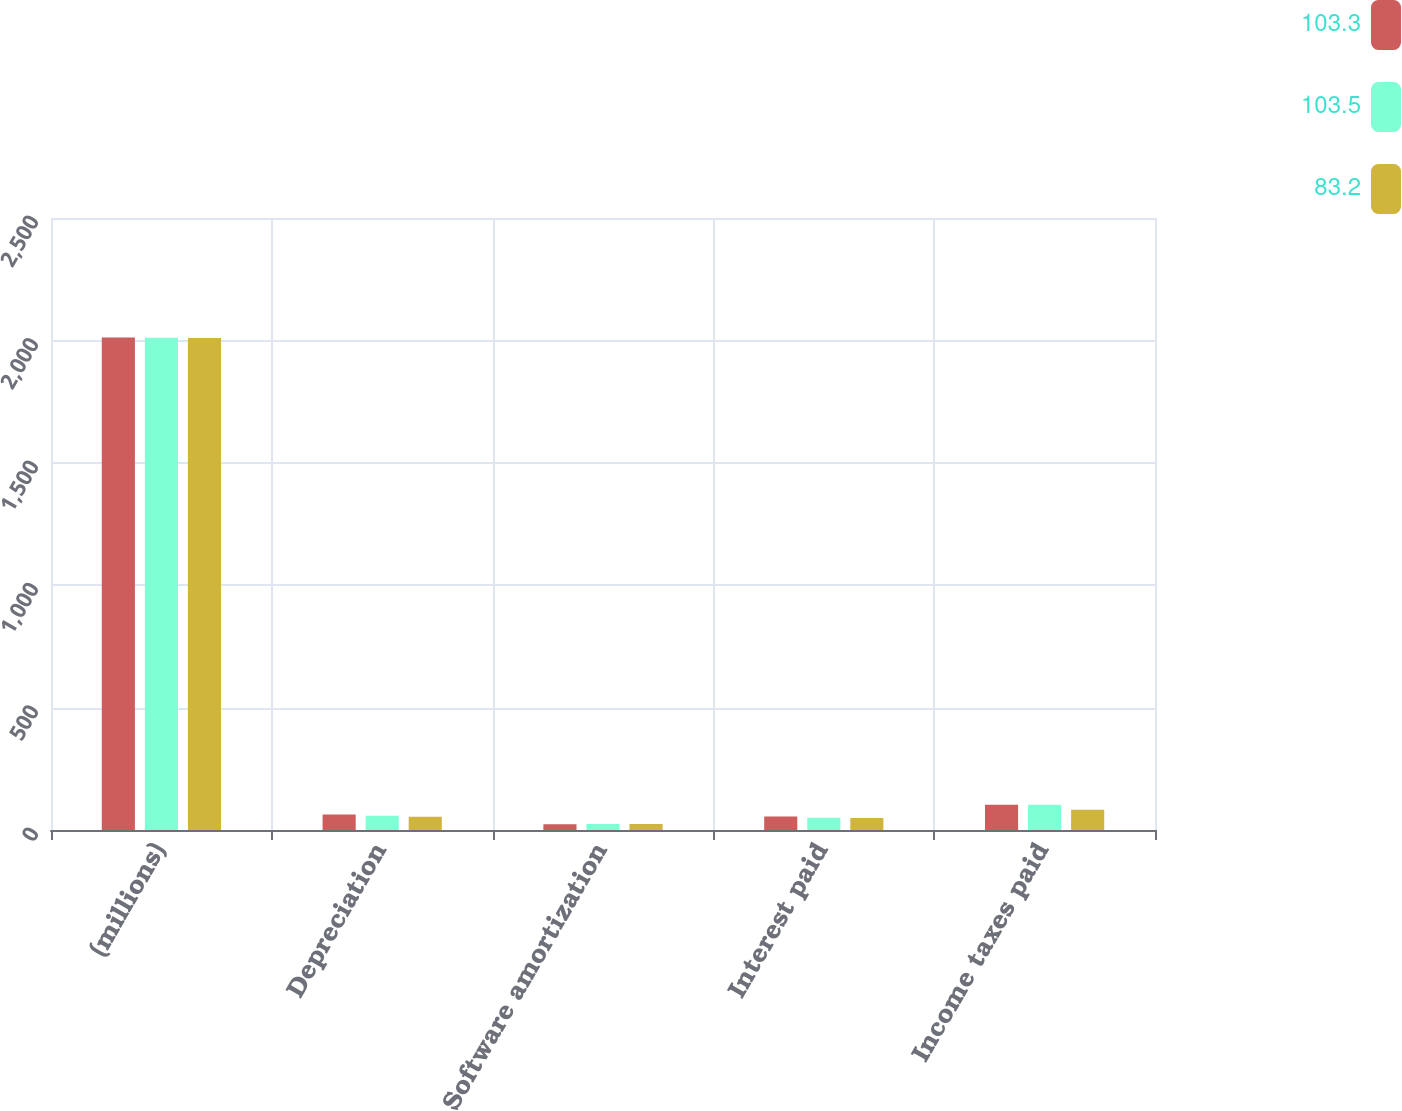Convert chart to OTSL. <chart><loc_0><loc_0><loc_500><loc_500><stacked_bar_chart><ecel><fcel>(millions)<fcel>Depreciation<fcel>Software amortization<fcel>Interest paid<fcel>Income taxes paid<nl><fcel>103.3<fcel>2012<fcel>63.6<fcel>23.7<fcel>54.7<fcel>103.3<nl><fcel>103.5<fcel>2011<fcel>58.1<fcel>24.4<fcel>49.6<fcel>103.5<nl><fcel>83.2<fcel>2010<fcel>54<fcel>25<fcel>49.3<fcel>83.2<nl></chart> 